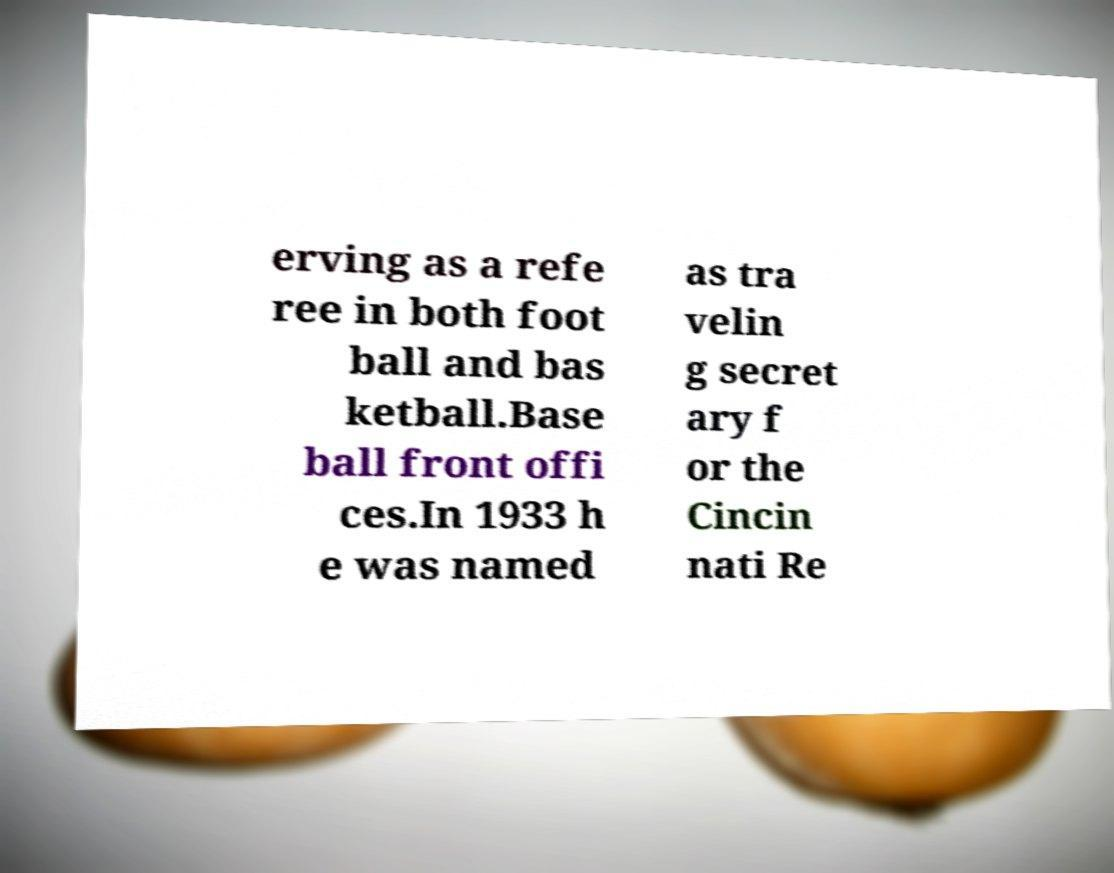Can you accurately transcribe the text from the provided image for me? erving as a refe ree in both foot ball and bas ketball.Base ball front offi ces.In 1933 h e was named as tra velin g secret ary f or the Cincin nati Re 